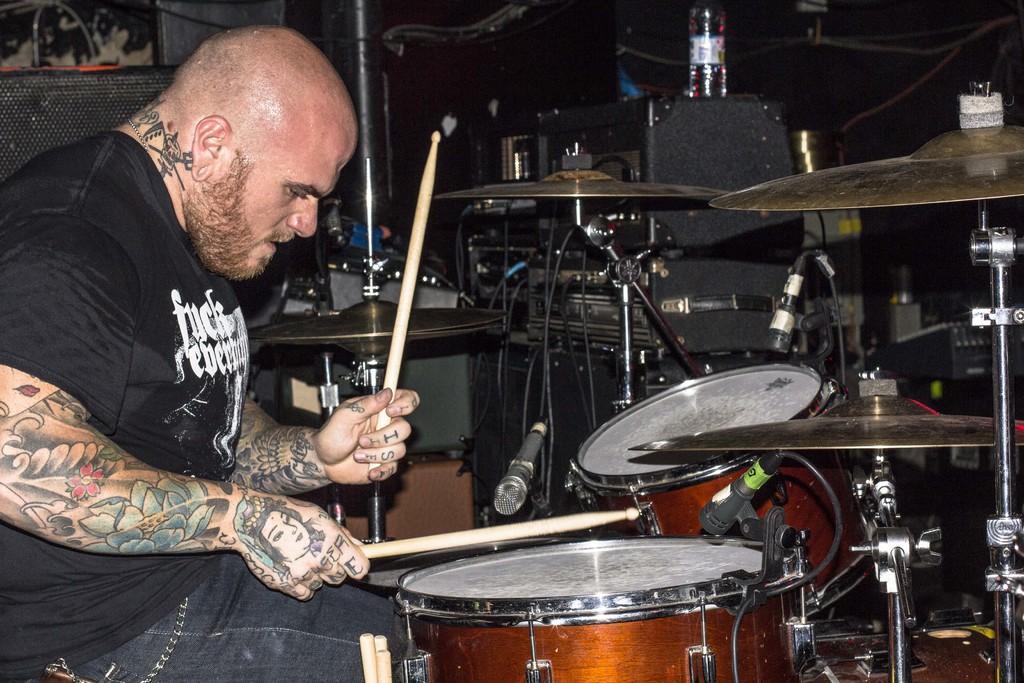Could you give a brief overview of what you see in this image? In this image I can see a person with black color t-shirt. and he is sitting in front of the drum set and playing it. There are tattoos on the person. In the back there is a bottle on the sound box. 